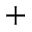<formula> <loc_0><loc_0><loc_500><loc_500>^ { + }</formula> 